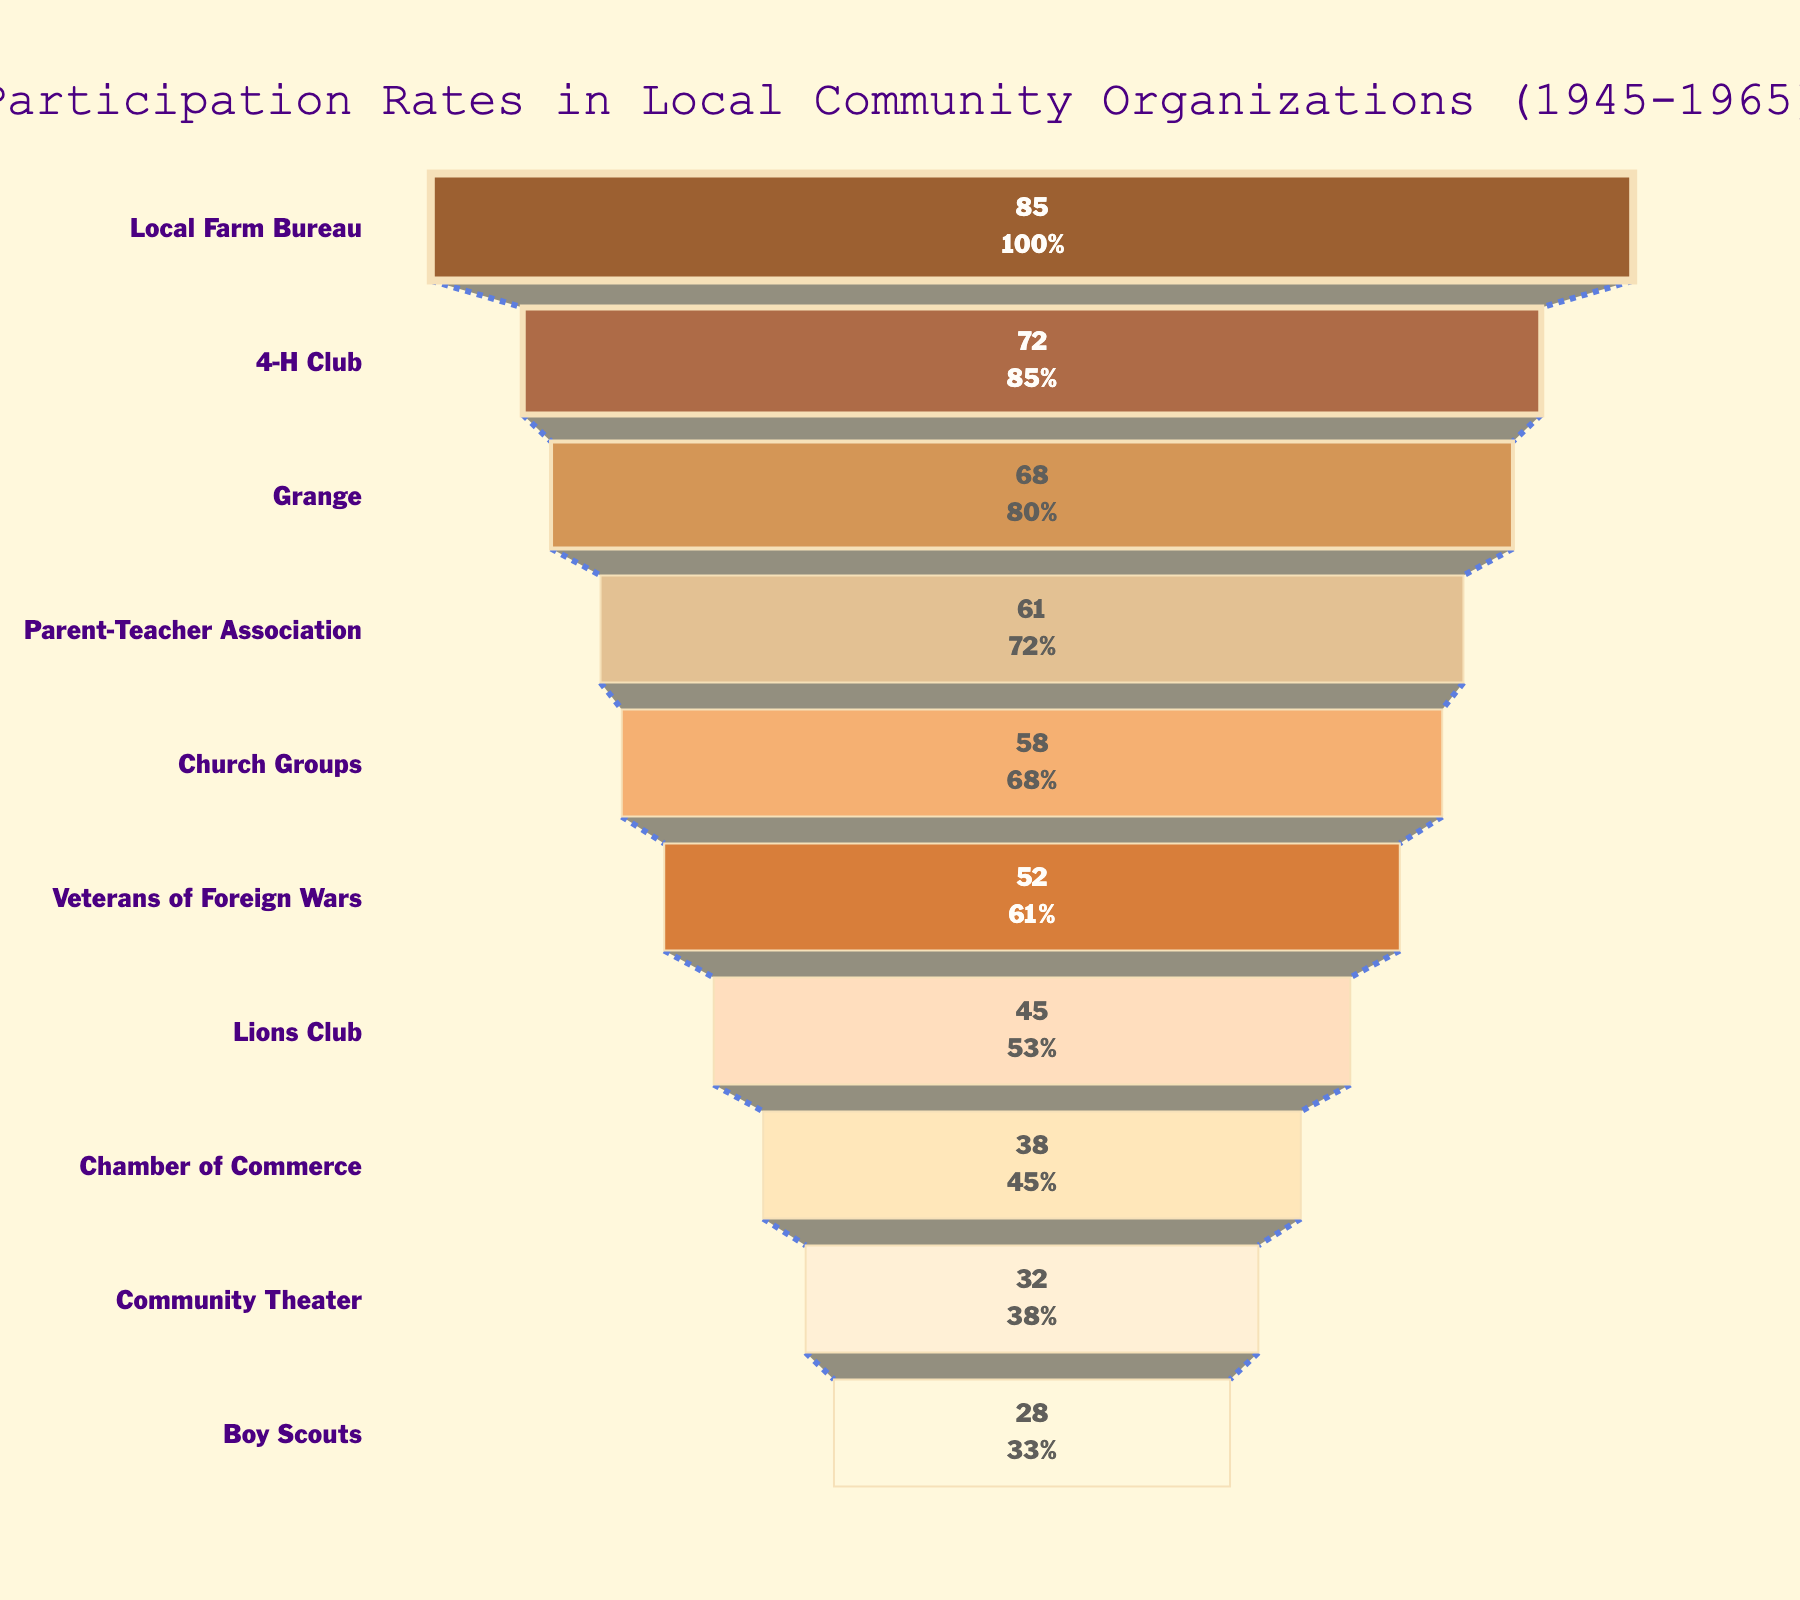What is the title of the figure? The title of the figure is typically located at the top and it summarizes what the visual represents. Here, it's given as "Participation Rates in Local Community Organizations (1945-1965)" as per the data description.
Answer: Participation Rates in Local Community Organizations (1945-1965) Which organization had the highest participation rate? The highest participation rate can be found at the widest part of the funnel chart. In this case, the Local Farm Bureau has the widest section with a rate of 85%.
Answer: Local Farm Bureau What percentage of the community participated in the 4-H Club? Referring to the funnel chart, the 4-H Club is the second entry and its participation rate is specified as 72%.
Answer: 72% How many organizations have participation rates above 50%? Look at the funnel chart and count the sections where the participation rate is greater than 50%. They are: Local Farm Bureau, 4-H Club, Grange, Parent-Teacher Association, Church Groups, and Veterans of Foreign Wars. Hence, there are six such organizations.
Answer: 6 What is the difference in participation rates between the Grange and the Boy Scouts? Subtract the participation rate of the Boy Scouts from the participation rate of the Grange: 68% - 28% = 40%.
Answer: 40% What is the average participation rate of the organizations shown? Add the participation rates of all the organizations and divide by the number of organizations: (85 + 72 + 68 + 61 + 58 + 52 + 45 + 38 + 32 + 28)/10 = 53.9%.
Answer: 53.9% Which organization is just above the Lions Club in participation rate? According to the sorted funnel chart, the organization just above the Lions Club, which has a rate of 45%, is the Veterans of Foreign Wars with a rate of 52%.
Answer: Veterans of Foreign Wars Between which two organizations is the steepest drop in participation rate observed? Look for the steepest drop between consecutive organizations in the funnel chart. The steepest drop is between the Parent-Teacher Association (61%) and Church Groups (58%), which is a difference of 3%.
Answer: Parent-Teacher Association and Church Groups What is the percentage increase in participation from the Community Theater to the Chamber of Commerce? First calculate the difference between their participation rates: 38% - 32% = 6%. Then, find the percentage increase relative to the participation rate of the Community Theater: (6/32) * 100% = 18.75%.
Answer: 18.75% 